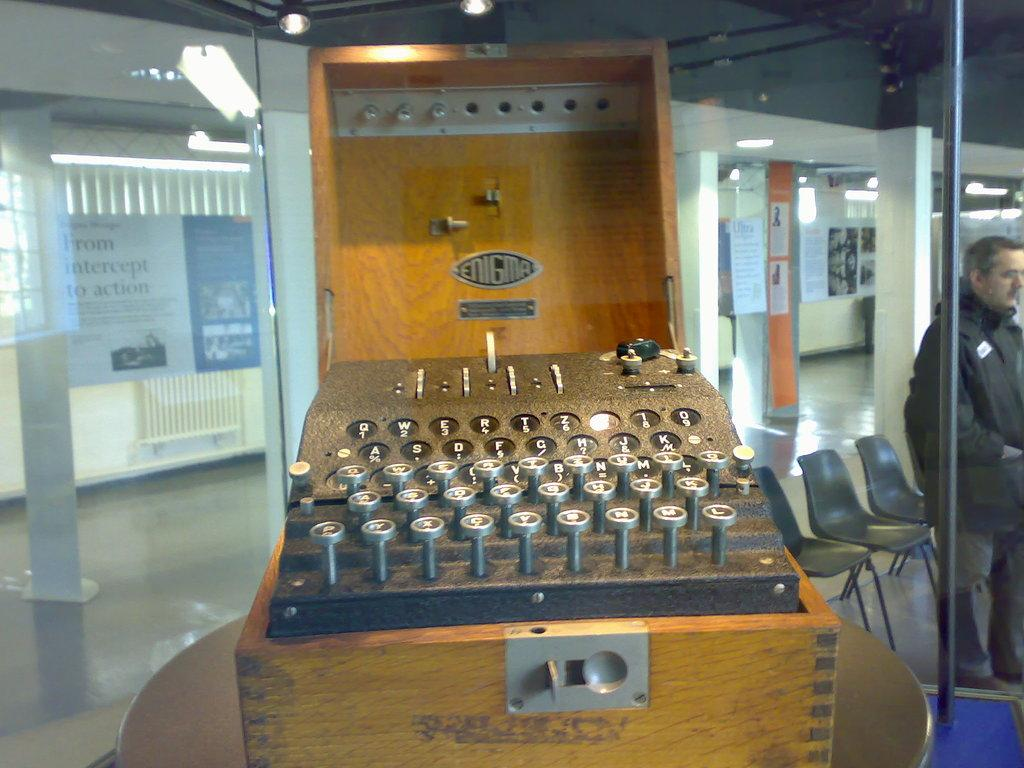Provide a one-sentence caption for the provided image. an old enigma cipher machine on display somewhere. 